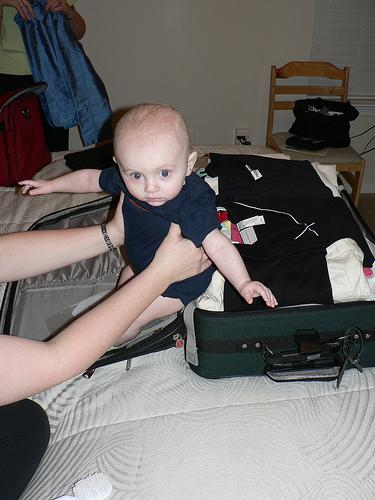Question: where is the picture taken?
Choices:
A. In a yard.
B. At the beach.
C. On a sidewalk.
D. A bedroom.
Answer with the letter. Answer: D Question: who is sitting on the suitcase?
Choices:
A. A baby.
B. A cat.
C. A woman.
D. A man.
Answer with the letter. Answer: A Question: what is in the suitcase?
Choices:
A. A cat.
B. Toiletries.
C. Towels.
D. Clothing.
Answer with the letter. Answer: D 